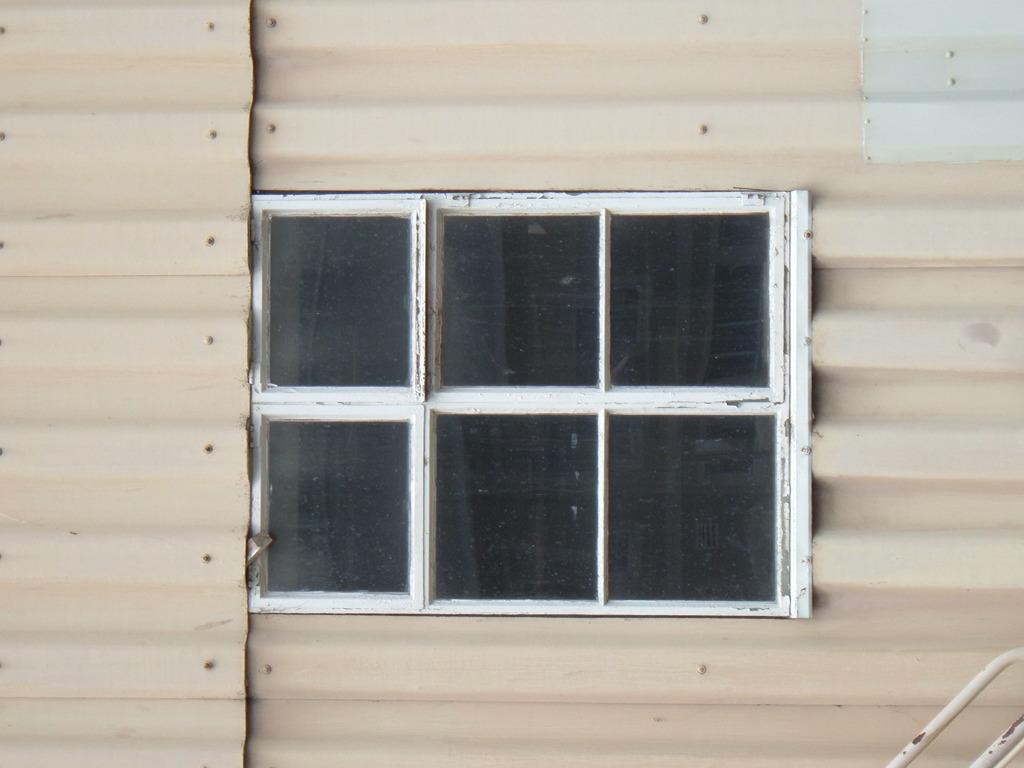What type of wall is visible in the image? There is a metal wall in the image. Is there any opening in the metal wall? Yes, there is a window attached to the metal wall. How many lizards can be seen climbing on the metal wall in the image? There are no lizards visible in the image. What type of vegetable is being used to dig the ground near the metal wall in the image? There is no vegetable or digging activity present in the image. 